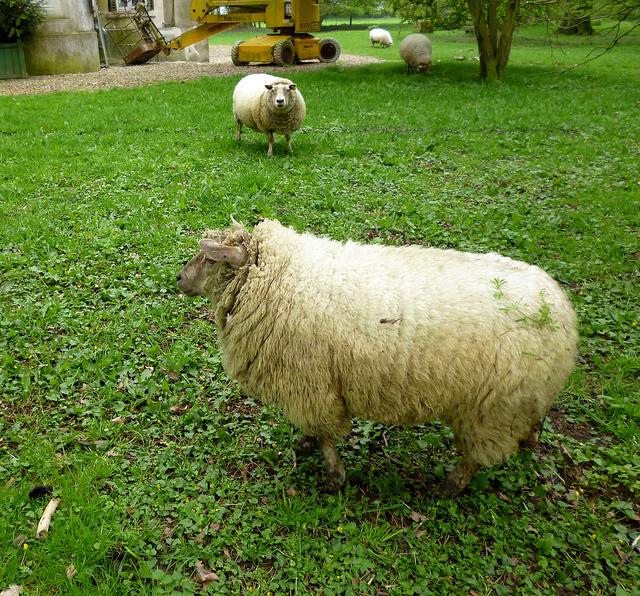Are the sheep standing or lying down?
Write a very short answer. Standing. How many sheep are there?
Quick response, please. 4. How many sheep?
Quick response, please. 4. What is the machinery in the background called?
Quick response, please. Lift. 